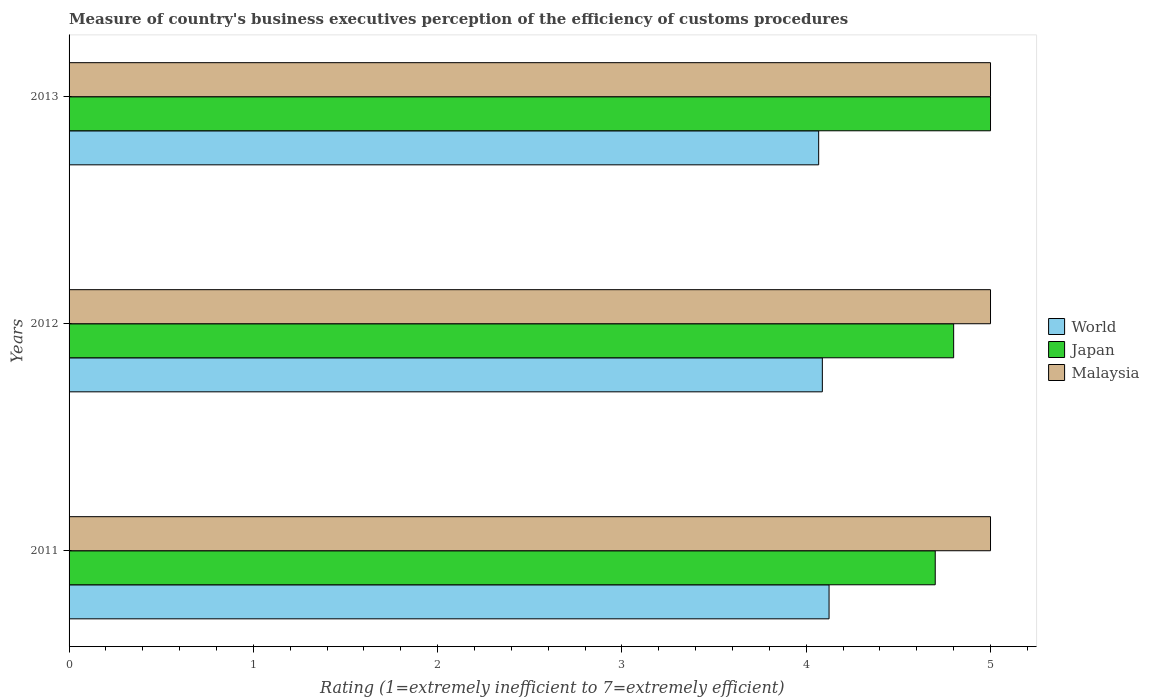Are the number of bars on each tick of the Y-axis equal?
Ensure brevity in your answer.  Yes. How many bars are there on the 3rd tick from the top?
Provide a short and direct response. 3. What is the label of the 1st group of bars from the top?
Ensure brevity in your answer.  2013. In how many cases, is the number of bars for a given year not equal to the number of legend labels?
Your answer should be very brief. 0. Across all years, what is the maximum rating of the efficiency of customs procedure in World?
Provide a succinct answer. 4.12. Across all years, what is the minimum rating of the efficiency of customs procedure in Malaysia?
Ensure brevity in your answer.  5. What is the difference between the rating of the efficiency of customs procedure in Malaysia in 2011 and that in 2013?
Your answer should be compact. 0. What is the difference between the rating of the efficiency of customs procedure in Japan in 2011 and the rating of the efficiency of customs procedure in Malaysia in 2012?
Your answer should be compact. -0.3. What is the average rating of the efficiency of customs procedure in Japan per year?
Offer a very short reply. 4.83. In the year 2011, what is the difference between the rating of the efficiency of customs procedure in Malaysia and rating of the efficiency of customs procedure in World?
Make the answer very short. 0.88. What is the ratio of the rating of the efficiency of customs procedure in Japan in 2011 to that in 2012?
Keep it short and to the point. 0.98. Is the rating of the efficiency of customs procedure in Malaysia in 2012 less than that in 2013?
Keep it short and to the point. No. Is the difference between the rating of the efficiency of customs procedure in Malaysia in 2012 and 2013 greater than the difference between the rating of the efficiency of customs procedure in World in 2012 and 2013?
Provide a succinct answer. No. What is the difference between the highest and the second highest rating of the efficiency of customs procedure in Japan?
Provide a short and direct response. 0.2. What is the difference between the highest and the lowest rating of the efficiency of customs procedure in Japan?
Ensure brevity in your answer.  0.3. In how many years, is the rating of the efficiency of customs procedure in Japan greater than the average rating of the efficiency of customs procedure in Japan taken over all years?
Provide a succinct answer. 1. Is the sum of the rating of the efficiency of customs procedure in Japan in 2012 and 2013 greater than the maximum rating of the efficiency of customs procedure in World across all years?
Make the answer very short. Yes. What does the 1st bar from the top in 2012 represents?
Your response must be concise. Malaysia. What does the 2nd bar from the bottom in 2013 represents?
Offer a very short reply. Japan. How many years are there in the graph?
Provide a succinct answer. 3. What is the difference between two consecutive major ticks on the X-axis?
Provide a succinct answer. 1. Are the values on the major ticks of X-axis written in scientific E-notation?
Your answer should be compact. No. How many legend labels are there?
Make the answer very short. 3. How are the legend labels stacked?
Give a very brief answer. Vertical. What is the title of the graph?
Provide a short and direct response. Measure of country's business executives perception of the efficiency of customs procedures. Does "Nicaragua" appear as one of the legend labels in the graph?
Your response must be concise. No. What is the label or title of the X-axis?
Keep it short and to the point. Rating (1=extremely inefficient to 7=extremely efficient). What is the Rating (1=extremely inefficient to 7=extremely efficient) in World in 2011?
Provide a short and direct response. 4.12. What is the Rating (1=extremely inefficient to 7=extremely efficient) of Malaysia in 2011?
Provide a succinct answer. 5. What is the Rating (1=extremely inefficient to 7=extremely efficient) of World in 2012?
Provide a succinct answer. 4.09. What is the Rating (1=extremely inefficient to 7=extremely efficient) in Malaysia in 2012?
Give a very brief answer. 5. What is the Rating (1=extremely inefficient to 7=extremely efficient) of World in 2013?
Offer a terse response. 4.07. What is the Rating (1=extremely inefficient to 7=extremely efficient) in Japan in 2013?
Provide a succinct answer. 5. What is the Rating (1=extremely inefficient to 7=extremely efficient) of Malaysia in 2013?
Offer a terse response. 5. Across all years, what is the maximum Rating (1=extremely inefficient to 7=extremely efficient) in World?
Offer a terse response. 4.12. Across all years, what is the maximum Rating (1=extremely inefficient to 7=extremely efficient) of Japan?
Provide a succinct answer. 5. Across all years, what is the maximum Rating (1=extremely inefficient to 7=extremely efficient) in Malaysia?
Offer a terse response. 5. Across all years, what is the minimum Rating (1=extremely inefficient to 7=extremely efficient) of World?
Provide a succinct answer. 4.07. What is the total Rating (1=extremely inefficient to 7=extremely efficient) of World in the graph?
Keep it short and to the point. 12.28. What is the difference between the Rating (1=extremely inefficient to 7=extremely efficient) of World in 2011 and that in 2012?
Keep it short and to the point. 0.04. What is the difference between the Rating (1=extremely inefficient to 7=extremely efficient) of Japan in 2011 and that in 2012?
Provide a succinct answer. -0.1. What is the difference between the Rating (1=extremely inefficient to 7=extremely efficient) in Malaysia in 2011 and that in 2012?
Your answer should be compact. 0. What is the difference between the Rating (1=extremely inefficient to 7=extremely efficient) in World in 2011 and that in 2013?
Your response must be concise. 0.06. What is the difference between the Rating (1=extremely inefficient to 7=extremely efficient) of World in 2012 and that in 2013?
Provide a short and direct response. 0.02. What is the difference between the Rating (1=extremely inefficient to 7=extremely efficient) in Malaysia in 2012 and that in 2013?
Ensure brevity in your answer.  0. What is the difference between the Rating (1=extremely inefficient to 7=extremely efficient) of World in 2011 and the Rating (1=extremely inefficient to 7=extremely efficient) of Japan in 2012?
Offer a terse response. -0.68. What is the difference between the Rating (1=extremely inefficient to 7=extremely efficient) in World in 2011 and the Rating (1=extremely inefficient to 7=extremely efficient) in Malaysia in 2012?
Your response must be concise. -0.88. What is the difference between the Rating (1=extremely inefficient to 7=extremely efficient) in Japan in 2011 and the Rating (1=extremely inefficient to 7=extremely efficient) in Malaysia in 2012?
Provide a short and direct response. -0.3. What is the difference between the Rating (1=extremely inefficient to 7=extremely efficient) in World in 2011 and the Rating (1=extremely inefficient to 7=extremely efficient) in Japan in 2013?
Offer a terse response. -0.88. What is the difference between the Rating (1=extremely inefficient to 7=extremely efficient) in World in 2011 and the Rating (1=extremely inefficient to 7=extremely efficient) in Malaysia in 2013?
Give a very brief answer. -0.88. What is the difference between the Rating (1=extremely inefficient to 7=extremely efficient) of World in 2012 and the Rating (1=extremely inefficient to 7=extremely efficient) of Japan in 2013?
Ensure brevity in your answer.  -0.91. What is the difference between the Rating (1=extremely inefficient to 7=extremely efficient) in World in 2012 and the Rating (1=extremely inefficient to 7=extremely efficient) in Malaysia in 2013?
Provide a succinct answer. -0.91. What is the difference between the Rating (1=extremely inefficient to 7=extremely efficient) in Japan in 2012 and the Rating (1=extremely inefficient to 7=extremely efficient) in Malaysia in 2013?
Keep it short and to the point. -0.2. What is the average Rating (1=extremely inefficient to 7=extremely efficient) of World per year?
Offer a terse response. 4.09. What is the average Rating (1=extremely inefficient to 7=extremely efficient) in Japan per year?
Offer a terse response. 4.83. What is the average Rating (1=extremely inefficient to 7=extremely efficient) of Malaysia per year?
Provide a short and direct response. 5. In the year 2011, what is the difference between the Rating (1=extremely inefficient to 7=extremely efficient) in World and Rating (1=extremely inefficient to 7=extremely efficient) in Japan?
Ensure brevity in your answer.  -0.58. In the year 2011, what is the difference between the Rating (1=extremely inefficient to 7=extremely efficient) of World and Rating (1=extremely inefficient to 7=extremely efficient) of Malaysia?
Your response must be concise. -0.88. In the year 2011, what is the difference between the Rating (1=extremely inefficient to 7=extremely efficient) in Japan and Rating (1=extremely inefficient to 7=extremely efficient) in Malaysia?
Offer a very short reply. -0.3. In the year 2012, what is the difference between the Rating (1=extremely inefficient to 7=extremely efficient) of World and Rating (1=extremely inefficient to 7=extremely efficient) of Japan?
Offer a terse response. -0.71. In the year 2012, what is the difference between the Rating (1=extremely inefficient to 7=extremely efficient) in World and Rating (1=extremely inefficient to 7=extremely efficient) in Malaysia?
Your answer should be very brief. -0.91. In the year 2012, what is the difference between the Rating (1=extremely inefficient to 7=extremely efficient) in Japan and Rating (1=extremely inefficient to 7=extremely efficient) in Malaysia?
Provide a short and direct response. -0.2. In the year 2013, what is the difference between the Rating (1=extremely inefficient to 7=extremely efficient) in World and Rating (1=extremely inefficient to 7=extremely efficient) in Japan?
Make the answer very short. -0.93. In the year 2013, what is the difference between the Rating (1=extremely inefficient to 7=extremely efficient) in World and Rating (1=extremely inefficient to 7=extremely efficient) in Malaysia?
Offer a very short reply. -0.93. What is the ratio of the Rating (1=extremely inefficient to 7=extremely efficient) of World in 2011 to that in 2012?
Ensure brevity in your answer.  1.01. What is the ratio of the Rating (1=extremely inefficient to 7=extremely efficient) in Japan in 2011 to that in 2012?
Make the answer very short. 0.98. What is the ratio of the Rating (1=extremely inefficient to 7=extremely efficient) in World in 2011 to that in 2013?
Make the answer very short. 1.01. What is the ratio of the Rating (1=extremely inefficient to 7=extremely efficient) in Japan in 2011 to that in 2013?
Provide a succinct answer. 0.94. What is the ratio of the Rating (1=extremely inefficient to 7=extremely efficient) of Malaysia in 2012 to that in 2013?
Offer a very short reply. 1. What is the difference between the highest and the second highest Rating (1=extremely inefficient to 7=extremely efficient) in World?
Provide a succinct answer. 0.04. What is the difference between the highest and the second highest Rating (1=extremely inefficient to 7=extremely efficient) in Malaysia?
Offer a terse response. 0. What is the difference between the highest and the lowest Rating (1=extremely inefficient to 7=extremely efficient) of World?
Your answer should be compact. 0.06. What is the difference between the highest and the lowest Rating (1=extremely inefficient to 7=extremely efficient) in Japan?
Ensure brevity in your answer.  0.3. What is the difference between the highest and the lowest Rating (1=extremely inefficient to 7=extremely efficient) of Malaysia?
Provide a short and direct response. 0. 